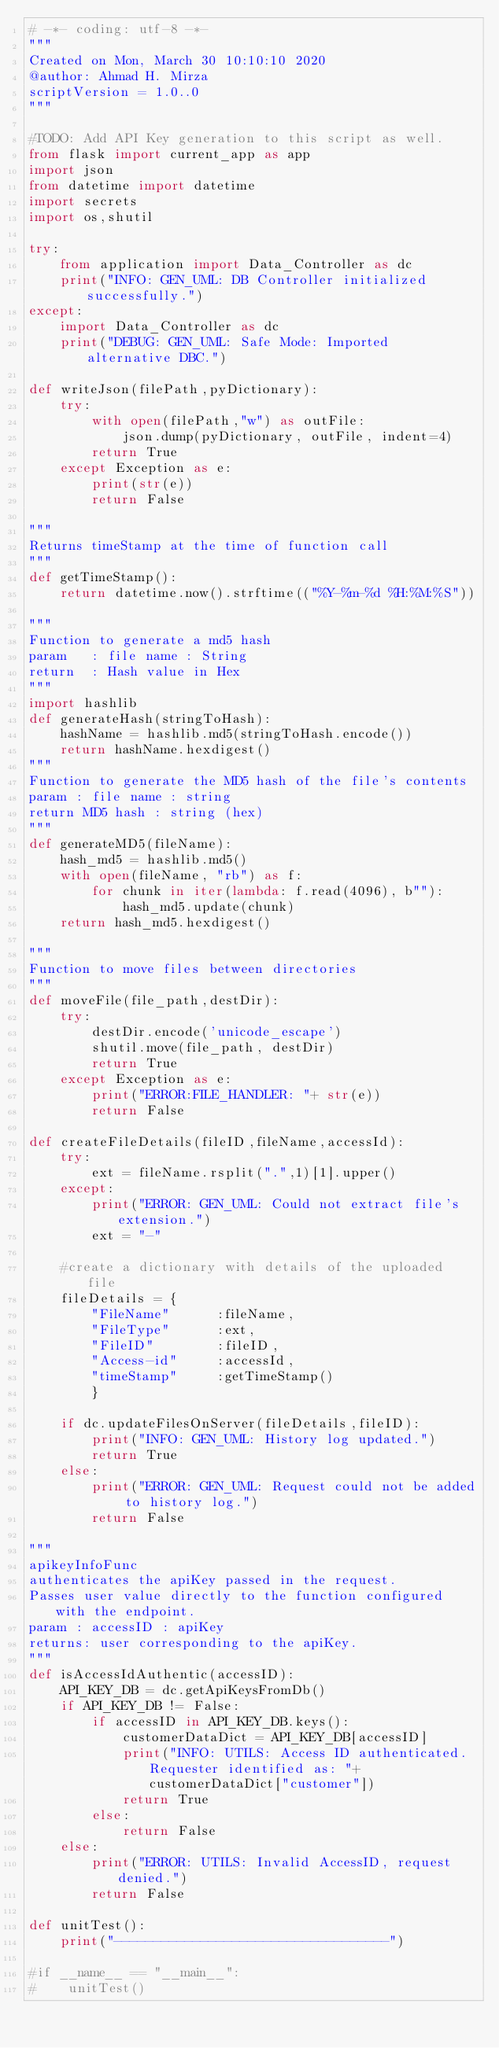Convert code to text. <code><loc_0><loc_0><loc_500><loc_500><_Python_># -*- coding: utf-8 -*-
"""
Created on Mon, March 30 10:10:10 2020
@author: Ahmad H. Mirza
scriptVersion = 1.0..0
"""

#TODO: Add API Key generation to this script as well.
from flask import current_app as app
import json
from datetime import datetime
import secrets
import os,shutil

try:
    from application import Data_Controller as dc 
    print("INFO: GEN_UML: DB Controller initialized successfully.")
except:
    import Data_Controller as dc
    print("DEBUG: GEN_UML: Safe Mode: Imported alternative DBC.")

def writeJson(filePath,pyDictionary):
    try:
        with open(filePath,"w") as outFile:
            json.dump(pyDictionary, outFile, indent=4)
        return True
    except Exception as e:
        print(str(e))
        return False
    
"""
Returns timeStamp at the time of function call
"""
def getTimeStamp():
    return datetime.now().strftime(("%Y-%m-%d %H:%M:%S"))

"""
Function to generate a md5 hash
param 	: file name : String
return 	: Hash value in Hex
"""
import hashlib
def generateHash(stringToHash):   
    hashName = hashlib.md5(stringToHash.encode())
    return hashName.hexdigest()
"""
Function to generate the MD5 hash of the file's contents
param : file name : string
return MD5 hash : string (hex)
"""
def generateMD5(fileName):
    hash_md5 = hashlib.md5()
    with open(fileName, "rb") as f:
        for chunk in iter(lambda: f.read(4096), b""):
            hash_md5.update(chunk)
    return hash_md5.hexdigest()
    
"""
Function to move files between directories
"""
def moveFile(file_path,destDir):
    try:
        destDir.encode('unicode_escape')
        shutil.move(file_path, destDir)
        return True
    except Exception as e:
        print("ERROR:FILE_HANDLER: "+ str(e))
        return False

def createFileDetails(fileID,fileName,accessId):
    try:    
        ext = fileName.rsplit(".",1)[1].upper()
    except:
        print("ERROR: GEN_UML: Could not extract file's extension.")
        ext = "-"

    #create a dictionary with details of the uploaded file
    fileDetails = {
        "FileName"      :fileName, 
        "FileType"      :ext,
        "FileID"        :fileID,
        "Access-id"     :accessId,
        "timeStamp"     :getTimeStamp()
        }

    if dc.updateFilesOnServer(fileDetails,fileID):
        print("INFO: GEN_UML: History log updated.")
        return True
    else:
        print("ERROR: GEN_UML: Request could not be added to history log.")
        return False

"""
apikeyInfoFunc
authenticates the apiKey passed in the request.
Passes user value directly to the function configured with the endpoint.
param : accessID : apiKey
returns: user corresponding to the apiKey.
""" 
def isAccessIdAuthentic(accessID):
    API_KEY_DB = dc.getApiKeysFromDb()
    if API_KEY_DB != False:
        if accessID in API_KEY_DB.keys():
            customerDataDict = API_KEY_DB[accessID]
            print("INFO: UTILS: Access ID authenticated. Requester identified as: "+ customerDataDict["customer"])
            return True
        else:
            return False
    else:
        print("ERROR: UTILS: Invalid AccessID, request denied.")
        return False

def unitTest():
    print("-----------------------------------")
      
#if __name__ == "__main__":
#    unitTest()

</code> 